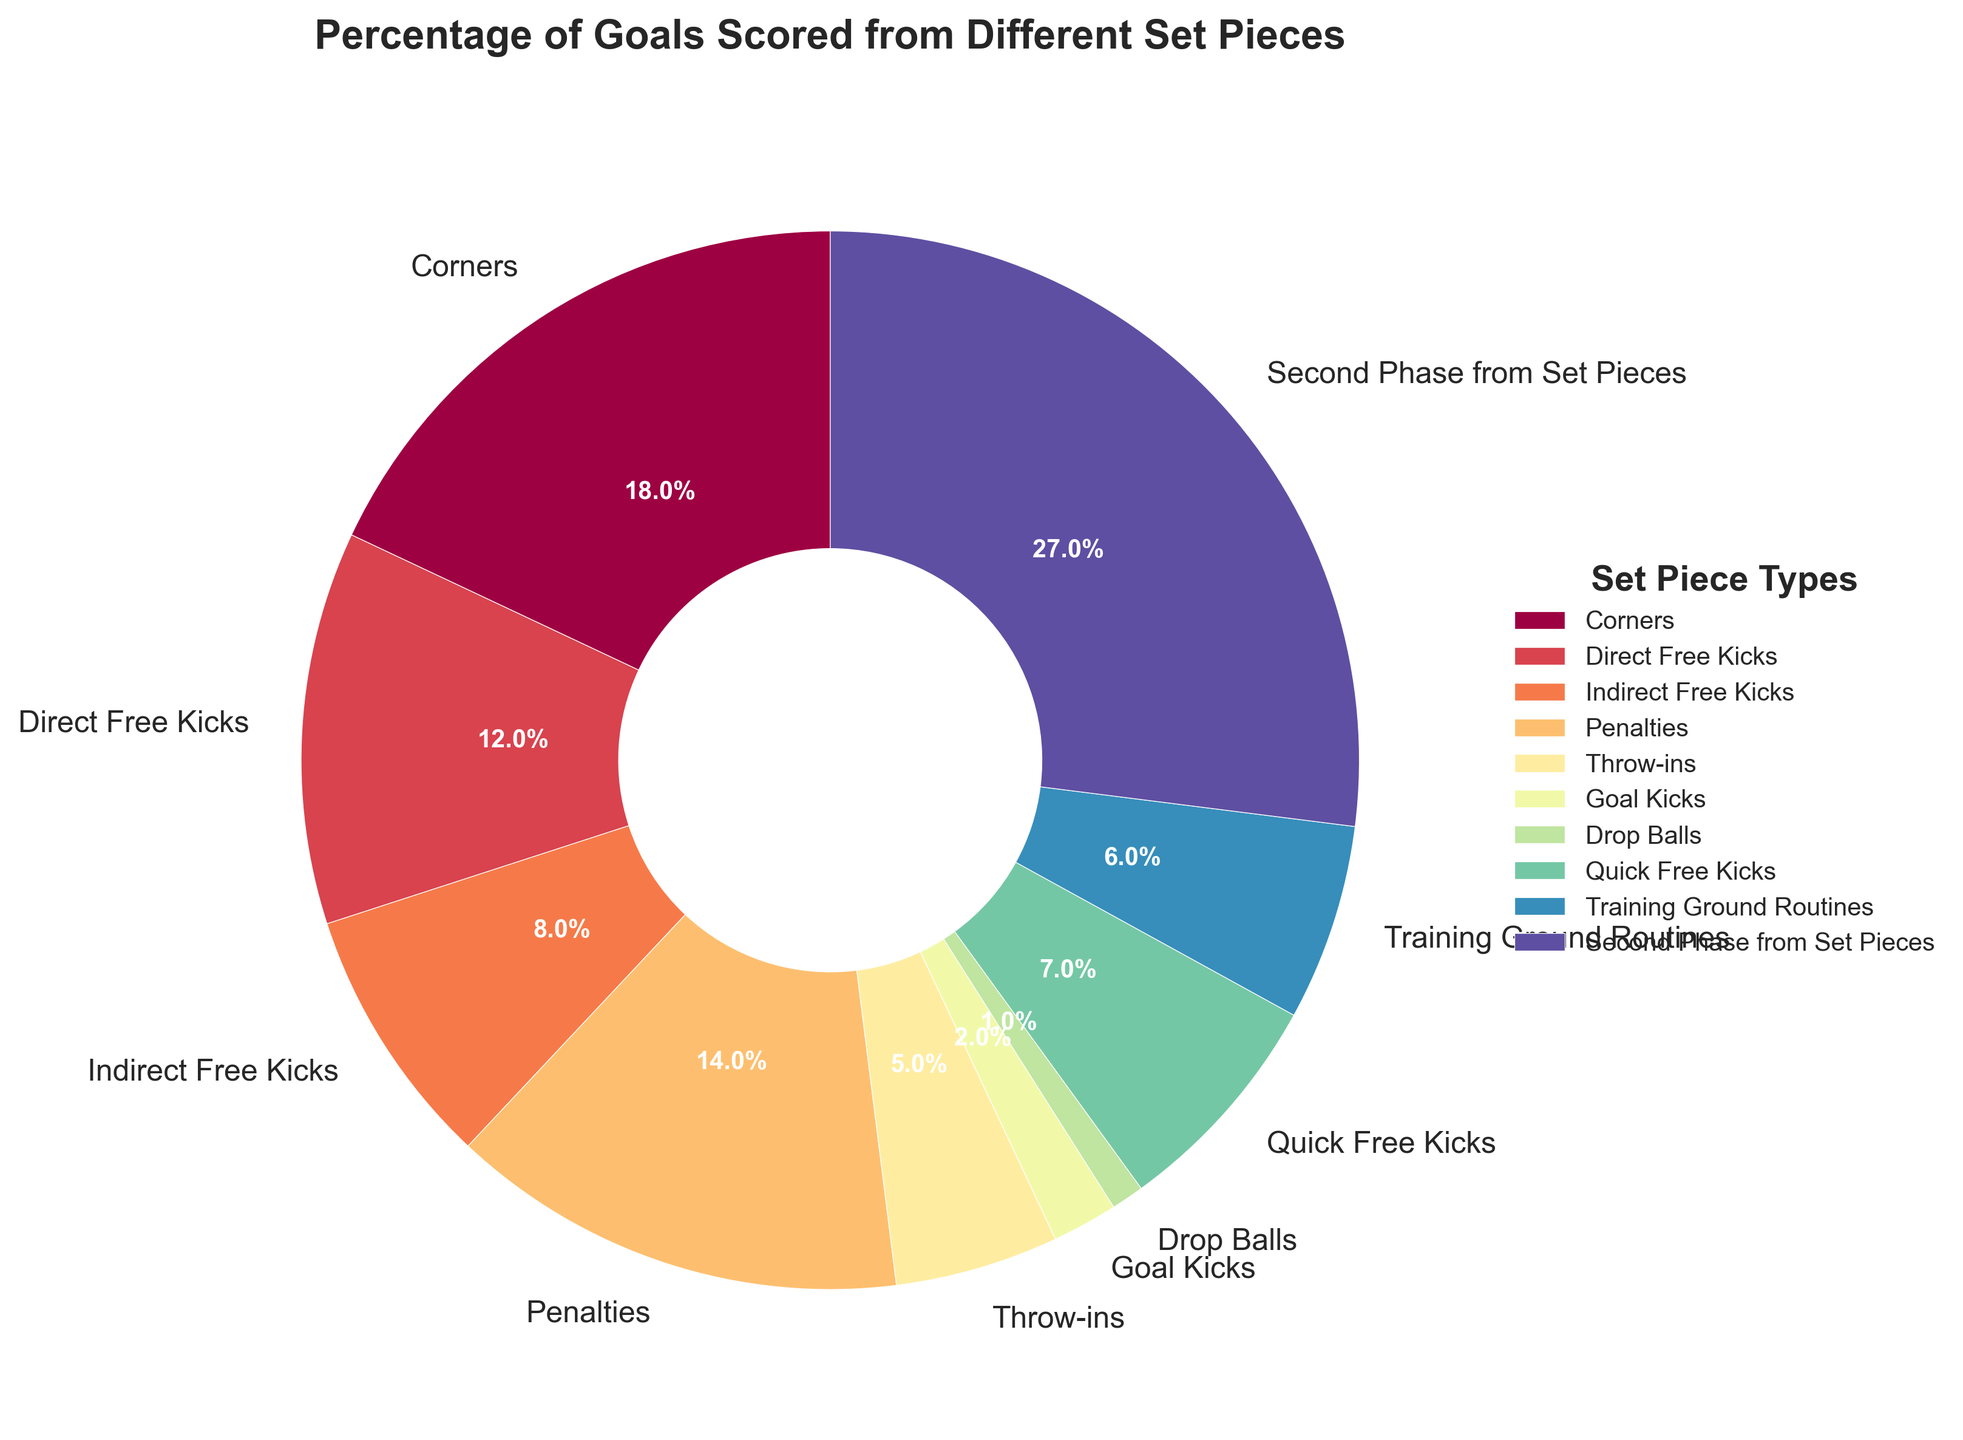Which set piece type accounts for the highest percentage of goals? The largest segment in the pie chart represents the type of set piece with the highest percentage. By examining the figure, the "Second Phase from Set Pieces" segment is the largest, showing a percentage of 27%.
Answer: Second Phase from Set Pieces What is the combined percentage of goals from Direct Free Kicks and Indirect Free Kicks? To find the combined percentage, sum the percentages from Direct Free Kicks (12%) and Indirect Free Kicks (8%) by adding 12 + 8 = 20%.
Answer: 20% Which set piece type has the least contribution to the total goals scored? The smallest segment in the pie chart represents the type of set piece with the least percentage. The "Drop Balls" segment is the smallest, indicating a percentage of 1%.
Answer: Drop Balls How does the percentage of goals from Penalties compare to Corners? Look at both segments for Penalties and Corners. Penalties account for 14%, and Corners for 18%. Since 14% is less than 18%, Penalties contribute less than Corners.
Answer: Less than Corners What is the difference in percentage between goals scored from Quick Free Kicks and Throw-ins? Subtract the percentage of Throw-ins (5%) from Quick Free Kicks (7%) by calculating 7 - 5 = 2%.
Answer: 2% What's the percentage of goals from set pieces other than Corners, Direct Free Kicks, and Penalties combined? First, find the percentage of goals from Corners, Direct Free Kicks, and Penalties (18% + 12% + 14% = 44%). Then subtract that from 100%: 100 - 44 = 56%.
Answer: 56% Which set pieces contribute more than 10% to the total goals? Identify the segments that are above 10%. These segments are "Corners" (18%), "Direct Free Kicks" (12%), "Penalties" (14%), and "Second Phase from Set Pieces" (27%).
Answer: Corners, Direct Free Kicks, Penalties, Second Phase from Set Pieces What is the average percentage of goals from Drop Balls, Goal Kicks, and Throw-ins? First, find the total percentage by summing the values (1% + 2% + 5% = 8%). Then, divide by the number of types (3): 8 / 3 ≈ 2.67%.
Answer: 2.67% Combine Training Ground Routines, Goal Kicks, and Drop Balls percentages. What part of 100% is it? Sum the percentages (6% + 2% + 1% = 9%). Then check what part this is of 100%: 9%.
Answer: 9% Compare the contribution of Quick Free Kicks and Training Ground Routines to the total goals. Which one contributes more and by how much? Examine the percentages for both: Quick Free Kicks (7%) and Training Ground Routines (6%). Since 7% is greater than 6%, Quick Free Kicks contribute more by a difference of 1%.
Answer: Quick Free Kicks by 1% 